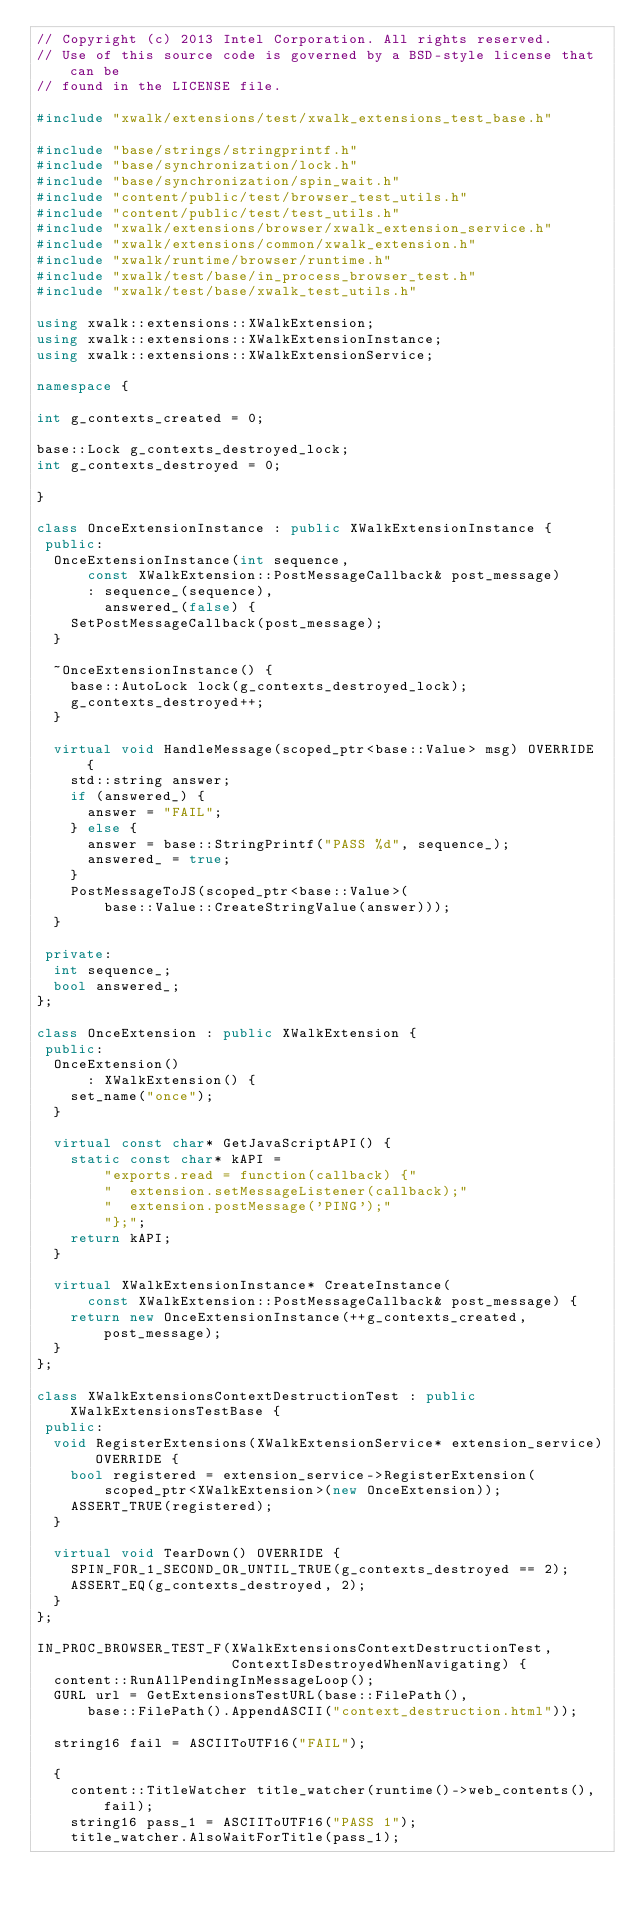<code> <loc_0><loc_0><loc_500><loc_500><_C++_>// Copyright (c) 2013 Intel Corporation. All rights reserved.
// Use of this source code is governed by a BSD-style license that can be
// found in the LICENSE file.

#include "xwalk/extensions/test/xwalk_extensions_test_base.h"

#include "base/strings/stringprintf.h"
#include "base/synchronization/lock.h"
#include "base/synchronization/spin_wait.h"
#include "content/public/test/browser_test_utils.h"
#include "content/public/test/test_utils.h"
#include "xwalk/extensions/browser/xwalk_extension_service.h"
#include "xwalk/extensions/common/xwalk_extension.h"
#include "xwalk/runtime/browser/runtime.h"
#include "xwalk/test/base/in_process_browser_test.h"
#include "xwalk/test/base/xwalk_test_utils.h"

using xwalk::extensions::XWalkExtension;
using xwalk::extensions::XWalkExtensionInstance;
using xwalk::extensions::XWalkExtensionService;

namespace {

int g_contexts_created = 0;

base::Lock g_contexts_destroyed_lock;
int g_contexts_destroyed = 0;

}

class OnceExtensionInstance : public XWalkExtensionInstance {
 public:
  OnceExtensionInstance(int sequence,
      const XWalkExtension::PostMessageCallback& post_message)
      : sequence_(sequence),
        answered_(false) {
    SetPostMessageCallback(post_message);
  }

  ~OnceExtensionInstance() {
    base::AutoLock lock(g_contexts_destroyed_lock);
    g_contexts_destroyed++;
  }

  virtual void HandleMessage(scoped_ptr<base::Value> msg) OVERRIDE {
    std::string answer;
    if (answered_) {
      answer = "FAIL";
    } else {
      answer = base::StringPrintf("PASS %d", sequence_);
      answered_ = true;
    }
    PostMessageToJS(scoped_ptr<base::Value>(
        base::Value::CreateStringValue(answer)));
  }

 private:
  int sequence_;
  bool answered_;
};

class OnceExtension : public XWalkExtension {
 public:
  OnceExtension()
      : XWalkExtension() {
    set_name("once");
  }

  virtual const char* GetJavaScriptAPI() {
    static const char* kAPI =
        "exports.read = function(callback) {"
        "  extension.setMessageListener(callback);"
        "  extension.postMessage('PING');"
        "};";
    return kAPI;
  }

  virtual XWalkExtensionInstance* CreateInstance(
      const XWalkExtension::PostMessageCallback& post_message) {
    return new OnceExtensionInstance(++g_contexts_created, post_message);
  }
};

class XWalkExtensionsContextDestructionTest : public XWalkExtensionsTestBase {
 public:
  void RegisterExtensions(XWalkExtensionService* extension_service) OVERRIDE {
    bool registered = extension_service->RegisterExtension(
        scoped_ptr<XWalkExtension>(new OnceExtension));
    ASSERT_TRUE(registered);
  }

  virtual void TearDown() OVERRIDE {
    SPIN_FOR_1_SECOND_OR_UNTIL_TRUE(g_contexts_destroyed == 2);
    ASSERT_EQ(g_contexts_destroyed, 2);
  }
};

IN_PROC_BROWSER_TEST_F(XWalkExtensionsContextDestructionTest,
                       ContextIsDestroyedWhenNavigating) {
  content::RunAllPendingInMessageLoop();
  GURL url = GetExtensionsTestURL(base::FilePath(),
      base::FilePath().AppendASCII("context_destruction.html"));

  string16 fail = ASCIIToUTF16("FAIL");

  {
    content::TitleWatcher title_watcher(runtime()->web_contents(), fail);
    string16 pass_1 = ASCIIToUTF16("PASS 1");
    title_watcher.AlsoWaitForTitle(pass_1);</code> 